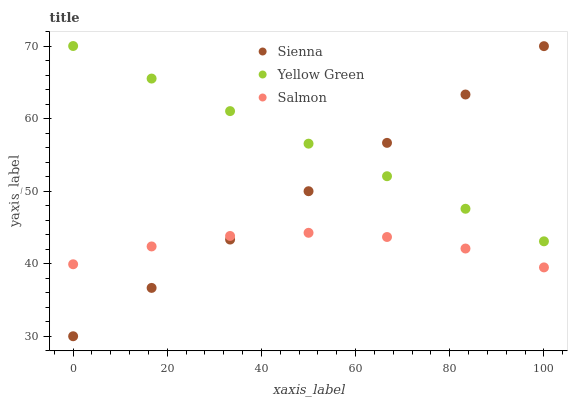Does Salmon have the minimum area under the curve?
Answer yes or no. Yes. Does Yellow Green have the maximum area under the curve?
Answer yes or no. Yes. Does Yellow Green have the minimum area under the curve?
Answer yes or no. No. Does Salmon have the maximum area under the curve?
Answer yes or no. No. Is Yellow Green the smoothest?
Answer yes or no. Yes. Is Salmon the roughest?
Answer yes or no. Yes. Is Salmon the smoothest?
Answer yes or no. No. Is Yellow Green the roughest?
Answer yes or no. No. Does Sienna have the lowest value?
Answer yes or no. Yes. Does Salmon have the lowest value?
Answer yes or no. No. Does Yellow Green have the highest value?
Answer yes or no. Yes. Does Salmon have the highest value?
Answer yes or no. No. Is Salmon less than Yellow Green?
Answer yes or no. Yes. Is Yellow Green greater than Salmon?
Answer yes or no. Yes. Does Sienna intersect Salmon?
Answer yes or no. Yes. Is Sienna less than Salmon?
Answer yes or no. No. Is Sienna greater than Salmon?
Answer yes or no. No. Does Salmon intersect Yellow Green?
Answer yes or no. No. 